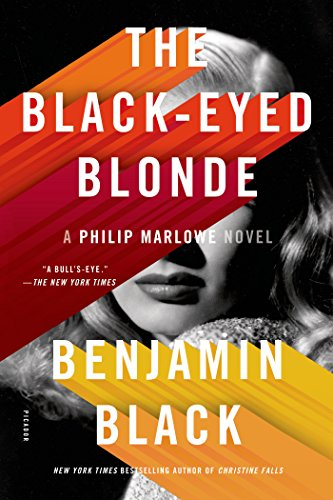What themes are explored in this Philip Marlowe novel? This novel explores themes such as betrayal, the complexities of human relationships, and the inevitable presence of moral ambiguity. It also delves into the impact of past decisions, showcasing how they haunt the characters, particularly in the case of the mysterious black-eyed blonde. 